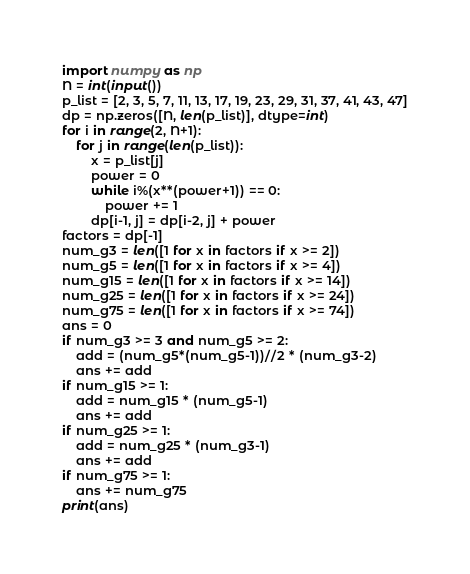Convert code to text. <code><loc_0><loc_0><loc_500><loc_500><_Python_>import numpy as np
N = int(input())
p_list = [2, 3, 5, 7, 11, 13, 17, 19, 23, 29, 31, 37, 41, 43, 47]
dp = np.zeros([N, len(p_list)], dtype=int)
for i in range(2, N+1):
    for j in range(len(p_list)):
        x = p_list[j]
        power = 0
        while i%(x**(power+1)) == 0:
            power += 1
        dp[i-1, j] = dp[i-2, j] + power
factors = dp[-1]
num_g3 = len([1 for x in factors if x >= 2])
num_g5 = len([1 for x in factors if x >= 4])
num_g15 = len([1 for x in factors if x >= 14])
num_g25 = len([1 for x in factors if x >= 24])
num_g75 = len([1 for x in factors if x >= 74])
ans = 0
if num_g3 >= 3 and num_g5 >= 2:
    add = (num_g5*(num_g5-1))//2 * (num_g3-2)
    ans += add
if num_g15 >= 1:
    add = num_g15 * (num_g5-1)
    ans += add
if num_g25 >= 1:
    add = num_g25 * (num_g3-1)
    ans += add
if num_g75 >= 1:
    ans += num_g75
print(ans)</code> 